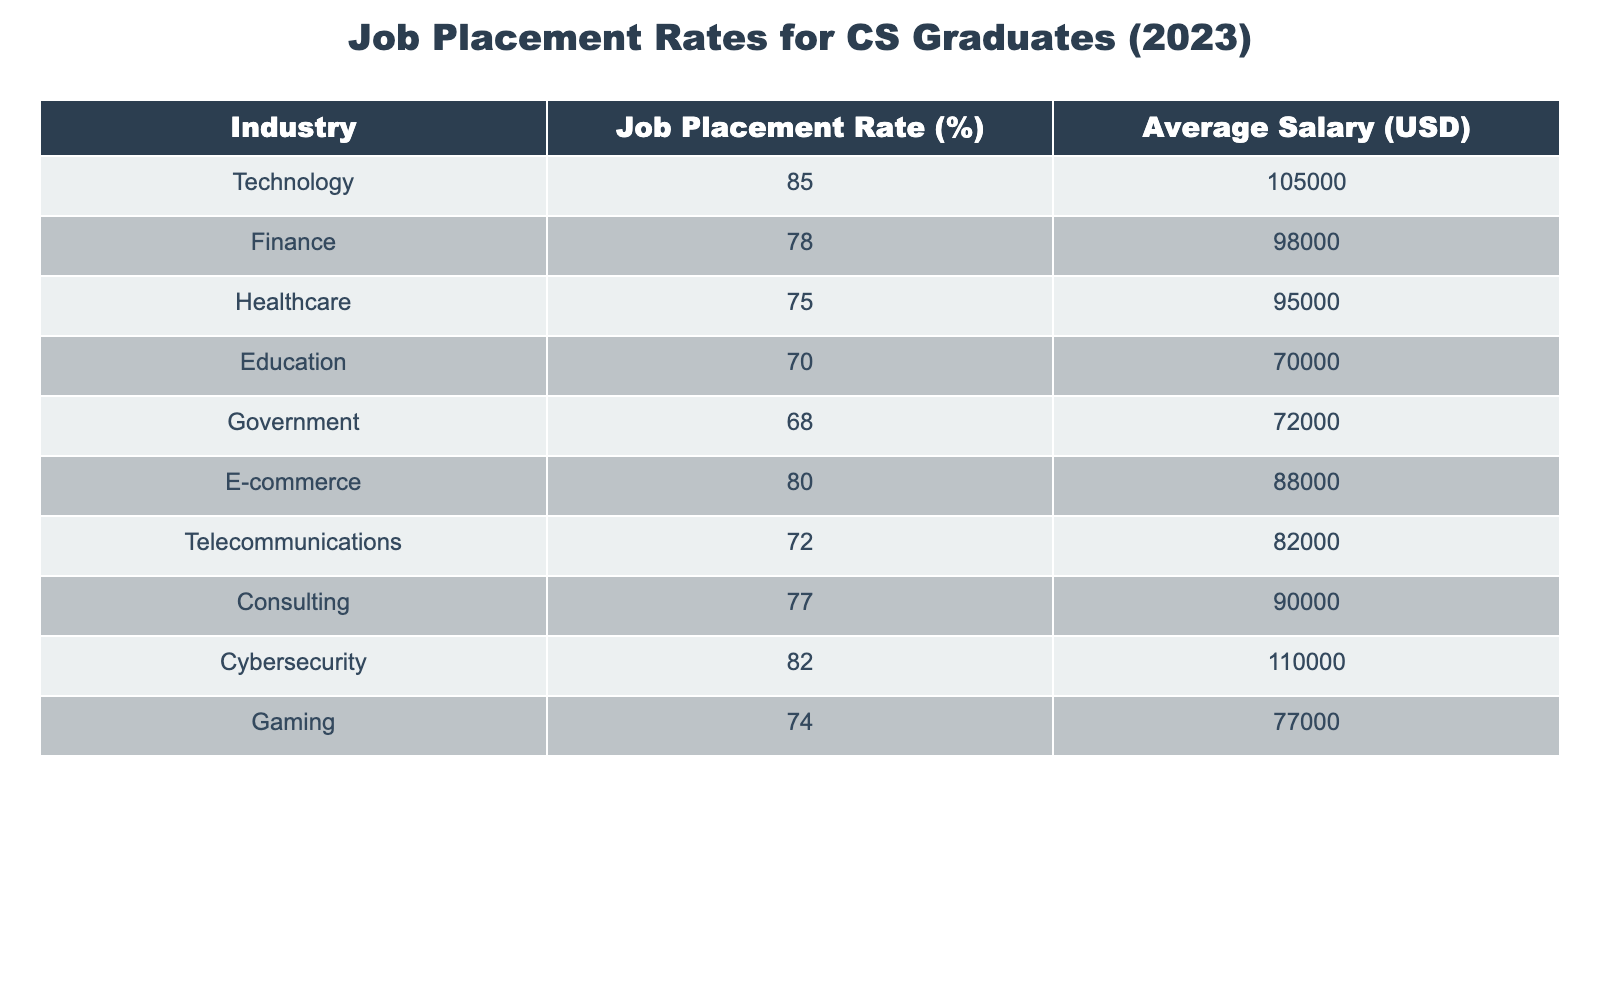What is the job placement rate in the Technology industry? The job placement rate for the Technology industry is explicitly stated in the table under the column "Job Placement Rate (%)" next to "Technology". It shows a value of 85%.
Answer: 85% Which industry has the lowest job placement rate? To find the industry with the lowest job placement rate, we compare all the values in the "Job Placement Rate (%)" column. The lowest value is 68%, which corresponds to the Government industry.
Answer: Government What is the average salary for Cybersecurity graduates? The average salary for the Cybersecurity industry can be found in the "Average Salary (USD)" column corresponding to the Cybersecurity row, which shows 110000 USD.
Answer: 110000 If a graduate chooses to work in Healthcare instead of E-commerce, how much more will they earn on average? First, we extract the average salaries for both industries: Healthcare has an average salary of 95000 USD and E-commerce has 88000 USD. The difference is 95000 - 88000 = 7000 USD. Therefore, they will earn 7000 USD more.
Answer: 7000 Is the job placement rate in the Gaming industry above 75%? The job placement rate for the Gaming industry is provided in the table, which is 74%. Since 74% is less than 75%, the statement is false.
Answer: No What is the average job placement rate of the top three industries by placement rate? The top three industries by job placement rate are Technology (85%), Cybersecurity (82%), and E-commerce (80%). We calculate the average by adding these rates: (85 + 82 + 80) / 3 = 81. The average job placement rate is thus 81%.
Answer: 81 In which industry can recent graduates expect a salary over 100000 USD? By examining the "Average Salary (USD)" column, we see that only the Technology and Cybersecurity industries have salaries over 100000 USD, with 105000 USD and 110000 USD respectively.
Answer: Technology and Cybersecurity Does the Consulting industry have a higher job placement rate than the Finance industry? From the table, we see the job placement rate for Consulting is 77% while for Finance it's 78%. Since 77% is less than 78%, the statement is false.
Answer: No 